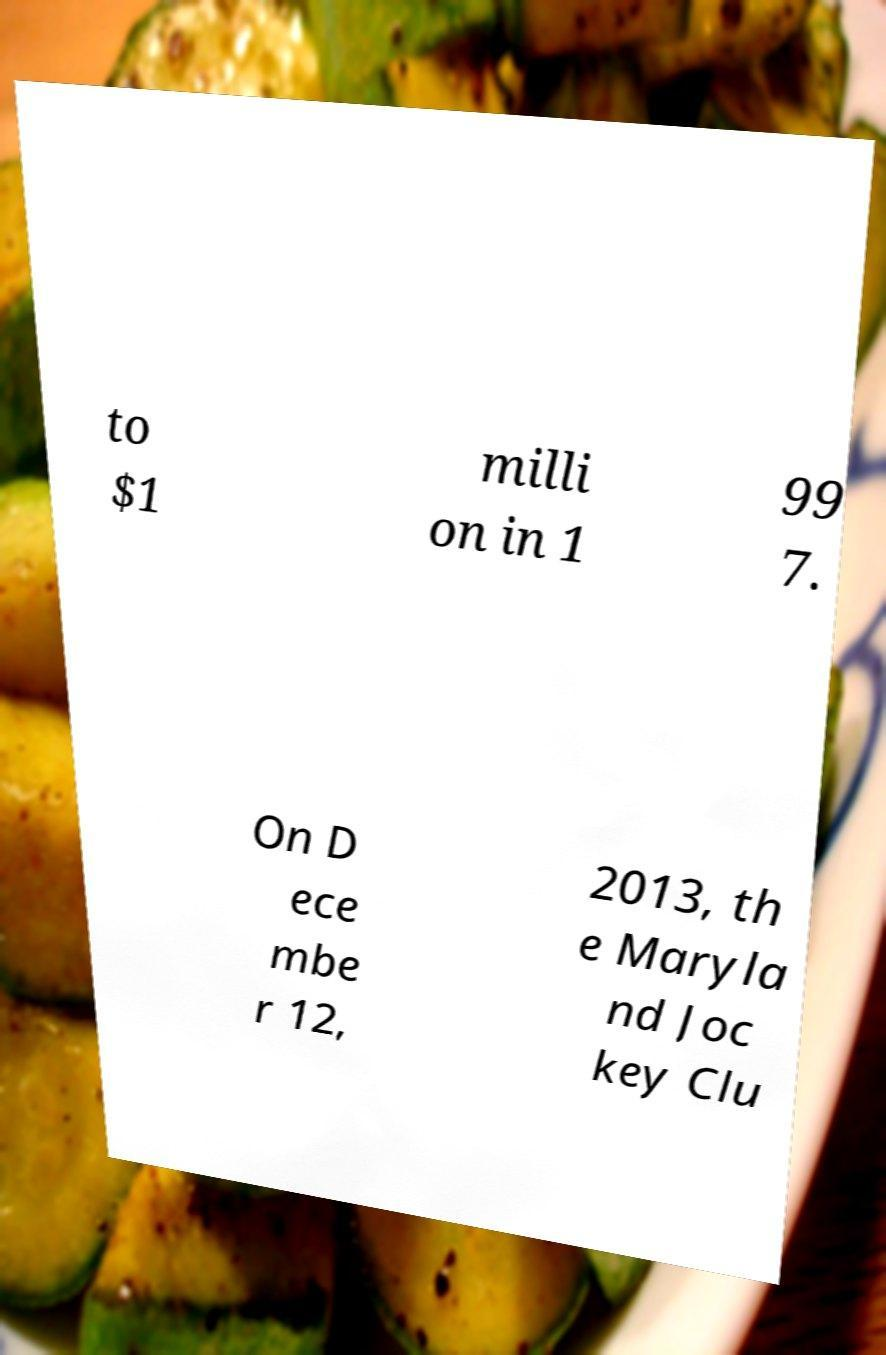Can you accurately transcribe the text from the provided image for me? to $1 milli on in 1 99 7. On D ece mbe r 12, 2013, th e Maryla nd Joc key Clu 